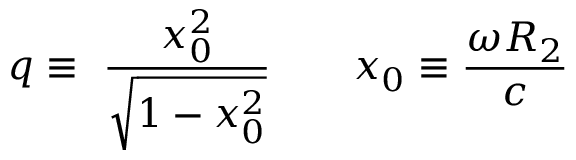Convert formula to latex. <formula><loc_0><loc_0><loc_500><loc_500>q \equiv \ \frac { x _ { 0 } ^ { 2 } } { \sqrt { 1 - x _ { 0 } ^ { 2 } } } \quad x _ { 0 } \equiv \frac { \omega R _ { 2 } } c</formula> 